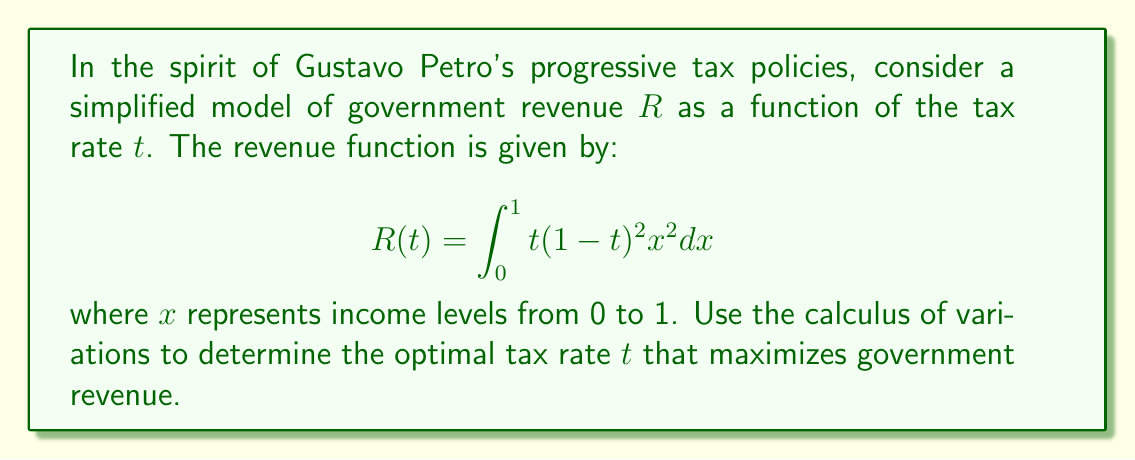Could you help me with this problem? To solve this problem, we'll use the Euler-Lagrange equation from the calculus of variations. However, in this case, our functional doesn't depend on t'(x), so we can treat it as a simple optimization problem.

Step 1: Evaluate the integral
$$R(t) = t\int_0^1 (1-t)^2 x^2 dx = t(1-t)^2 \left[\frac{x^3}{3}\right]_0^1 = \frac{t(1-t)^2}{3}$$

Step 2: Find the critical points by taking the derivative and setting it equal to zero
$$\frac{dR}{dt} = \frac{(1-t)^2}{3} - \frac{2t(1-t)}{3} = \frac{1-4t+3t^2}{3} = 0$$

Step 3: Solve the resulting quadratic equation
$$1-4t+3t^2 = 0$$
$$(3t-1)(t-1) = 0$$
$$t = \frac{1}{3} \text{ or } t = 1$$

Step 4: Evaluate the second derivative to determine the nature of critical points
$$\frac{d^2R}{dt^2} = \frac{-4+6t}{3}$$

At $t = \frac{1}{3}$: $\frac{d^2R}{dt^2} = -\frac{2}{3} < 0$ (local maximum)
At $t = 1$: $\frac{d^2R}{dt^2} = \frac{2}{3} > 0$ (local minimum)

Step 5: Compare the values of R at the critical points and endpoints
$$R(\frac{1}{3}) = \frac{\frac{1}{3}(1-\frac{1}{3})^2}{3} = \frac{4}{81} \approx 0.0494$$
$$R(1) = 0$$
$$R(0) = 0$$

Therefore, the optimal tax rate that maximizes government revenue is $\frac{1}{3}$ or approximately 33.33%.
Answer: $\frac{1}{3}$ 